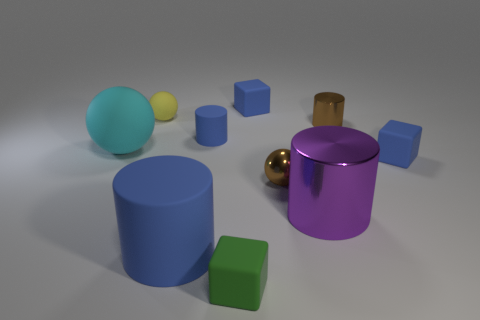Do the small yellow rubber object and the green matte object have the same shape?
Provide a short and direct response. No. What size is the yellow sphere?
Provide a short and direct response. Small. Is the number of blue objects behind the big metallic cylinder greater than the number of yellow matte spheres that are in front of the brown shiny cylinder?
Give a very brief answer. Yes. There is a big blue matte thing; are there any cylinders to the right of it?
Ensure brevity in your answer.  Yes. Is there a cyan metal cube that has the same size as the purple metallic thing?
Offer a very short reply. No. There is a tiny sphere that is made of the same material as the large ball; what color is it?
Your answer should be very brief. Yellow. What material is the brown sphere?
Offer a terse response. Metal. The large shiny thing has what shape?
Offer a terse response. Cylinder. What number of other metal balls are the same color as the big ball?
Offer a terse response. 0. There is a tiny cylinder right of the tiny blue rubber object that is behind the small cylinder that is on the right side of the small rubber cylinder; what is it made of?
Ensure brevity in your answer.  Metal. 